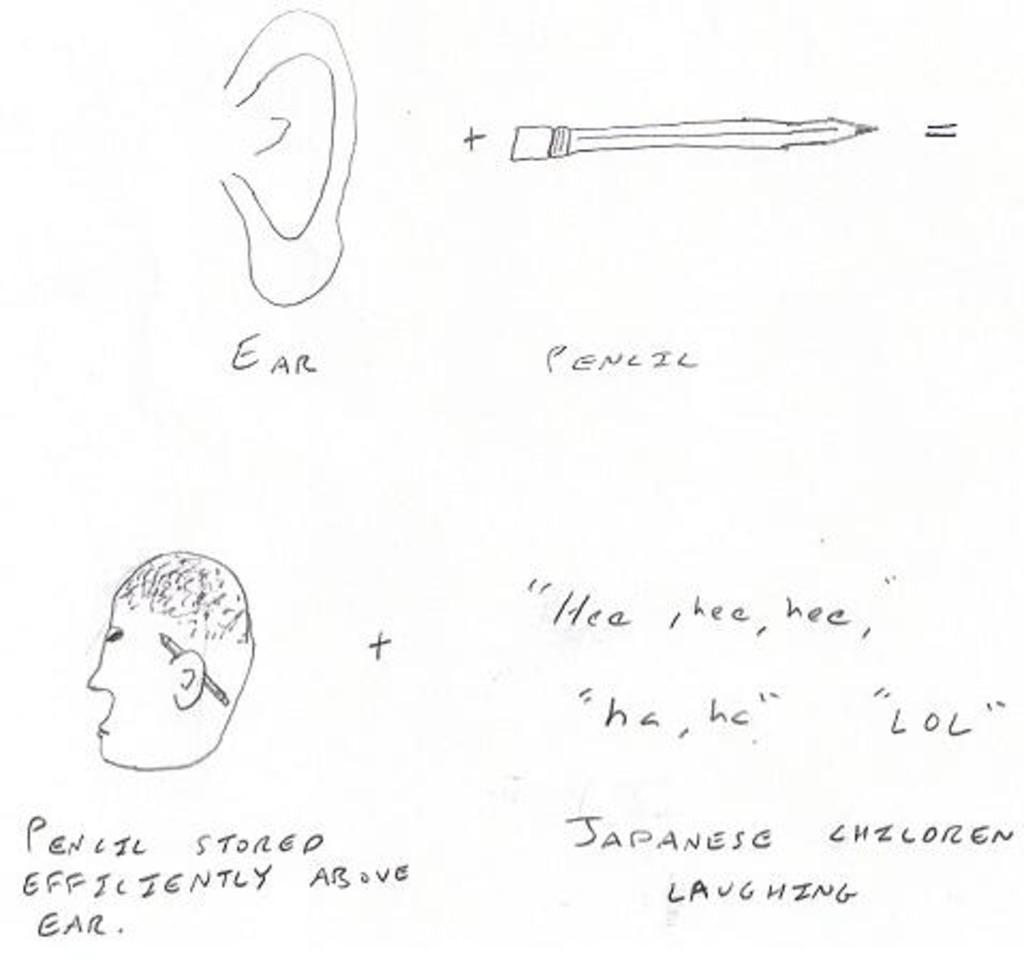<image>
Provide a brief description of the given image. a pencil drawing of an EAR and PENCIL with the pencil put behind the ear 